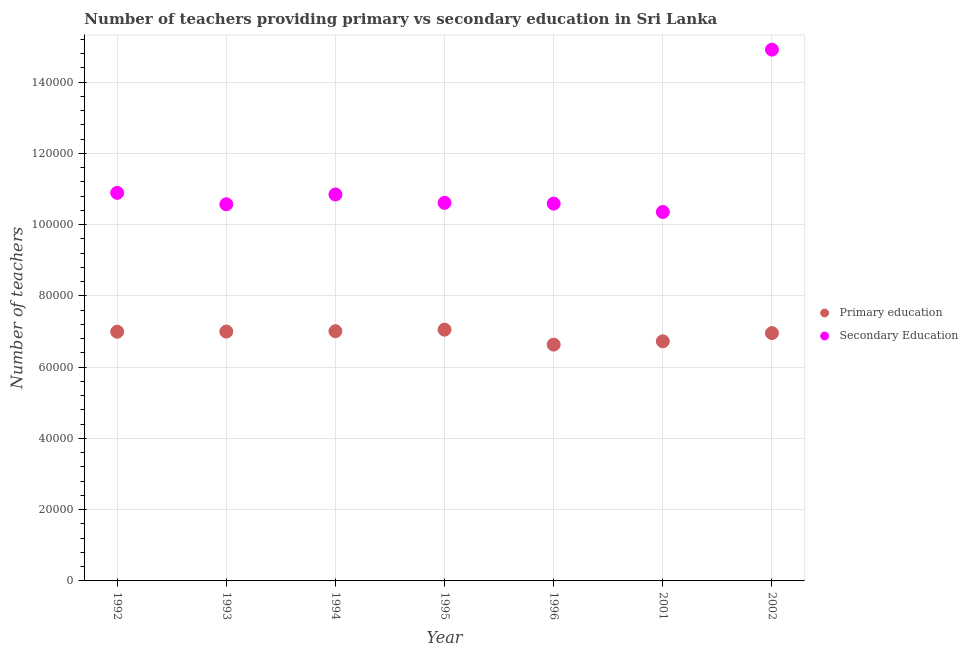How many different coloured dotlines are there?
Make the answer very short. 2. Is the number of dotlines equal to the number of legend labels?
Offer a terse response. Yes. What is the number of primary teachers in 2001?
Provide a short and direct response. 6.73e+04. Across all years, what is the maximum number of primary teachers?
Your answer should be very brief. 7.05e+04. Across all years, what is the minimum number of primary teachers?
Offer a very short reply. 6.63e+04. In which year was the number of secondary teachers minimum?
Offer a terse response. 2001. What is the total number of primary teachers in the graph?
Ensure brevity in your answer.  4.84e+05. What is the difference between the number of primary teachers in 1992 and that in 1993?
Offer a terse response. -43. What is the difference between the number of primary teachers in 1993 and the number of secondary teachers in 1996?
Offer a terse response. -3.59e+04. What is the average number of primary teachers per year?
Offer a very short reply. 6.91e+04. In the year 1993, what is the difference between the number of primary teachers and number of secondary teachers?
Offer a terse response. -3.57e+04. What is the ratio of the number of secondary teachers in 1994 to that in 1995?
Ensure brevity in your answer.  1.02. Is the number of primary teachers in 1996 less than that in 2002?
Keep it short and to the point. Yes. What is the difference between the highest and the second highest number of primary teachers?
Provide a short and direct response. 429. What is the difference between the highest and the lowest number of secondary teachers?
Offer a terse response. 4.56e+04. In how many years, is the number of primary teachers greater than the average number of primary teachers taken over all years?
Your answer should be very brief. 5. Does the number of primary teachers monotonically increase over the years?
Provide a succinct answer. No. Is the number of primary teachers strictly less than the number of secondary teachers over the years?
Keep it short and to the point. Yes. How many dotlines are there?
Keep it short and to the point. 2. How many years are there in the graph?
Offer a terse response. 7. What is the difference between two consecutive major ticks on the Y-axis?
Make the answer very short. 2.00e+04. Does the graph contain any zero values?
Provide a succinct answer. No. Does the graph contain grids?
Your response must be concise. Yes. How many legend labels are there?
Give a very brief answer. 2. How are the legend labels stacked?
Give a very brief answer. Vertical. What is the title of the graph?
Offer a terse response. Number of teachers providing primary vs secondary education in Sri Lanka. What is the label or title of the Y-axis?
Provide a succinct answer. Number of teachers. What is the Number of teachers of Primary education in 1992?
Keep it short and to the point. 7.00e+04. What is the Number of teachers in Secondary Education in 1992?
Give a very brief answer. 1.09e+05. What is the Number of teachers in Primary education in 1993?
Keep it short and to the point. 7.00e+04. What is the Number of teachers in Secondary Education in 1993?
Provide a succinct answer. 1.06e+05. What is the Number of teachers of Primary education in 1994?
Ensure brevity in your answer.  7.01e+04. What is the Number of teachers in Secondary Education in 1994?
Provide a succinct answer. 1.08e+05. What is the Number of teachers in Primary education in 1995?
Your answer should be very brief. 7.05e+04. What is the Number of teachers in Secondary Education in 1995?
Make the answer very short. 1.06e+05. What is the Number of teachers of Primary education in 1996?
Give a very brief answer. 6.63e+04. What is the Number of teachers of Secondary Education in 1996?
Your answer should be very brief. 1.06e+05. What is the Number of teachers in Primary education in 2001?
Your answer should be compact. 6.73e+04. What is the Number of teachers of Secondary Education in 2001?
Provide a short and direct response. 1.04e+05. What is the Number of teachers in Primary education in 2002?
Provide a succinct answer. 6.96e+04. What is the Number of teachers of Secondary Education in 2002?
Offer a very short reply. 1.49e+05. Across all years, what is the maximum Number of teachers in Primary education?
Make the answer very short. 7.05e+04. Across all years, what is the maximum Number of teachers in Secondary Education?
Offer a very short reply. 1.49e+05. Across all years, what is the minimum Number of teachers in Primary education?
Make the answer very short. 6.63e+04. Across all years, what is the minimum Number of teachers in Secondary Education?
Provide a short and direct response. 1.04e+05. What is the total Number of teachers in Primary education in the graph?
Offer a very short reply. 4.84e+05. What is the total Number of teachers of Secondary Education in the graph?
Make the answer very short. 7.88e+05. What is the difference between the Number of teachers in Primary education in 1992 and that in 1993?
Make the answer very short. -43. What is the difference between the Number of teachers of Secondary Education in 1992 and that in 1993?
Make the answer very short. 3202. What is the difference between the Number of teachers in Primary education in 1992 and that in 1994?
Make the answer very short. -143. What is the difference between the Number of teachers of Secondary Education in 1992 and that in 1994?
Your answer should be very brief. 455. What is the difference between the Number of teachers in Primary education in 1992 and that in 1995?
Your answer should be very brief. -572. What is the difference between the Number of teachers of Secondary Education in 1992 and that in 1995?
Make the answer very short. 2803. What is the difference between the Number of teachers of Primary education in 1992 and that in 1996?
Your answer should be very brief. 3626. What is the difference between the Number of teachers of Secondary Education in 1992 and that in 1996?
Make the answer very short. 3028. What is the difference between the Number of teachers of Primary education in 1992 and that in 2001?
Make the answer very short. 2700. What is the difference between the Number of teachers of Secondary Education in 1992 and that in 2001?
Offer a very short reply. 5372. What is the difference between the Number of teachers in Primary education in 1992 and that in 2002?
Provide a short and direct response. 395. What is the difference between the Number of teachers of Secondary Education in 1992 and that in 2002?
Your answer should be very brief. -4.02e+04. What is the difference between the Number of teachers in Primary education in 1993 and that in 1994?
Provide a succinct answer. -100. What is the difference between the Number of teachers of Secondary Education in 1993 and that in 1994?
Provide a short and direct response. -2747. What is the difference between the Number of teachers of Primary education in 1993 and that in 1995?
Your answer should be very brief. -529. What is the difference between the Number of teachers in Secondary Education in 1993 and that in 1995?
Your response must be concise. -399. What is the difference between the Number of teachers of Primary education in 1993 and that in 1996?
Offer a terse response. 3669. What is the difference between the Number of teachers in Secondary Education in 1993 and that in 1996?
Provide a short and direct response. -174. What is the difference between the Number of teachers of Primary education in 1993 and that in 2001?
Make the answer very short. 2743. What is the difference between the Number of teachers in Secondary Education in 1993 and that in 2001?
Your response must be concise. 2170. What is the difference between the Number of teachers of Primary education in 1993 and that in 2002?
Offer a terse response. 438. What is the difference between the Number of teachers of Secondary Education in 1993 and that in 2002?
Your response must be concise. -4.34e+04. What is the difference between the Number of teachers of Primary education in 1994 and that in 1995?
Keep it short and to the point. -429. What is the difference between the Number of teachers in Secondary Education in 1994 and that in 1995?
Keep it short and to the point. 2348. What is the difference between the Number of teachers of Primary education in 1994 and that in 1996?
Keep it short and to the point. 3769. What is the difference between the Number of teachers in Secondary Education in 1994 and that in 1996?
Give a very brief answer. 2573. What is the difference between the Number of teachers in Primary education in 1994 and that in 2001?
Offer a very short reply. 2843. What is the difference between the Number of teachers of Secondary Education in 1994 and that in 2001?
Your response must be concise. 4917. What is the difference between the Number of teachers in Primary education in 1994 and that in 2002?
Offer a terse response. 538. What is the difference between the Number of teachers of Secondary Education in 1994 and that in 2002?
Your answer should be compact. -4.07e+04. What is the difference between the Number of teachers of Primary education in 1995 and that in 1996?
Offer a terse response. 4198. What is the difference between the Number of teachers in Secondary Education in 1995 and that in 1996?
Offer a terse response. 225. What is the difference between the Number of teachers of Primary education in 1995 and that in 2001?
Offer a terse response. 3272. What is the difference between the Number of teachers in Secondary Education in 1995 and that in 2001?
Offer a terse response. 2569. What is the difference between the Number of teachers in Primary education in 1995 and that in 2002?
Your response must be concise. 967. What is the difference between the Number of teachers in Secondary Education in 1995 and that in 2002?
Ensure brevity in your answer.  -4.30e+04. What is the difference between the Number of teachers of Primary education in 1996 and that in 2001?
Provide a succinct answer. -926. What is the difference between the Number of teachers in Secondary Education in 1996 and that in 2001?
Your answer should be compact. 2344. What is the difference between the Number of teachers in Primary education in 1996 and that in 2002?
Give a very brief answer. -3231. What is the difference between the Number of teachers of Secondary Education in 1996 and that in 2002?
Your answer should be very brief. -4.32e+04. What is the difference between the Number of teachers in Primary education in 2001 and that in 2002?
Give a very brief answer. -2305. What is the difference between the Number of teachers of Secondary Education in 2001 and that in 2002?
Ensure brevity in your answer.  -4.56e+04. What is the difference between the Number of teachers in Primary education in 1992 and the Number of teachers in Secondary Education in 1993?
Offer a very short reply. -3.58e+04. What is the difference between the Number of teachers of Primary education in 1992 and the Number of teachers of Secondary Education in 1994?
Give a very brief answer. -3.85e+04. What is the difference between the Number of teachers of Primary education in 1992 and the Number of teachers of Secondary Education in 1995?
Your answer should be compact. -3.62e+04. What is the difference between the Number of teachers in Primary education in 1992 and the Number of teachers in Secondary Education in 1996?
Ensure brevity in your answer.  -3.60e+04. What is the difference between the Number of teachers in Primary education in 1992 and the Number of teachers in Secondary Education in 2001?
Provide a succinct answer. -3.36e+04. What is the difference between the Number of teachers in Primary education in 1992 and the Number of teachers in Secondary Education in 2002?
Keep it short and to the point. -7.92e+04. What is the difference between the Number of teachers in Primary education in 1993 and the Number of teachers in Secondary Education in 1994?
Your response must be concise. -3.85e+04. What is the difference between the Number of teachers in Primary education in 1993 and the Number of teachers in Secondary Education in 1995?
Provide a succinct answer. -3.61e+04. What is the difference between the Number of teachers in Primary education in 1993 and the Number of teachers in Secondary Education in 1996?
Your answer should be compact. -3.59e+04. What is the difference between the Number of teachers of Primary education in 1993 and the Number of teachers of Secondary Education in 2001?
Offer a very short reply. -3.36e+04. What is the difference between the Number of teachers in Primary education in 1993 and the Number of teachers in Secondary Education in 2002?
Keep it short and to the point. -7.91e+04. What is the difference between the Number of teachers in Primary education in 1994 and the Number of teachers in Secondary Education in 1995?
Provide a succinct answer. -3.60e+04. What is the difference between the Number of teachers in Primary education in 1994 and the Number of teachers in Secondary Education in 1996?
Give a very brief answer. -3.58e+04. What is the difference between the Number of teachers in Primary education in 1994 and the Number of teachers in Secondary Education in 2001?
Provide a succinct answer. -3.35e+04. What is the difference between the Number of teachers in Primary education in 1994 and the Number of teachers in Secondary Education in 2002?
Your response must be concise. -7.90e+04. What is the difference between the Number of teachers of Primary education in 1995 and the Number of teachers of Secondary Education in 1996?
Keep it short and to the point. -3.54e+04. What is the difference between the Number of teachers in Primary education in 1995 and the Number of teachers in Secondary Education in 2001?
Provide a short and direct response. -3.30e+04. What is the difference between the Number of teachers of Primary education in 1995 and the Number of teachers of Secondary Education in 2002?
Offer a terse response. -7.86e+04. What is the difference between the Number of teachers in Primary education in 1996 and the Number of teachers in Secondary Education in 2001?
Provide a short and direct response. -3.72e+04. What is the difference between the Number of teachers of Primary education in 1996 and the Number of teachers of Secondary Education in 2002?
Ensure brevity in your answer.  -8.28e+04. What is the difference between the Number of teachers in Primary education in 2001 and the Number of teachers in Secondary Education in 2002?
Ensure brevity in your answer.  -8.19e+04. What is the average Number of teachers of Primary education per year?
Give a very brief answer. 6.91e+04. What is the average Number of teachers of Secondary Education per year?
Provide a short and direct response. 1.13e+05. In the year 1992, what is the difference between the Number of teachers in Primary education and Number of teachers in Secondary Education?
Give a very brief answer. -3.90e+04. In the year 1993, what is the difference between the Number of teachers of Primary education and Number of teachers of Secondary Education?
Your answer should be compact. -3.57e+04. In the year 1994, what is the difference between the Number of teachers of Primary education and Number of teachers of Secondary Education?
Your response must be concise. -3.84e+04. In the year 1995, what is the difference between the Number of teachers of Primary education and Number of teachers of Secondary Education?
Your response must be concise. -3.56e+04. In the year 1996, what is the difference between the Number of teachers of Primary education and Number of teachers of Secondary Education?
Your response must be concise. -3.96e+04. In the year 2001, what is the difference between the Number of teachers in Primary education and Number of teachers in Secondary Education?
Make the answer very short. -3.63e+04. In the year 2002, what is the difference between the Number of teachers of Primary education and Number of teachers of Secondary Education?
Give a very brief answer. -7.96e+04. What is the ratio of the Number of teachers of Secondary Education in 1992 to that in 1993?
Ensure brevity in your answer.  1.03. What is the ratio of the Number of teachers in Primary education in 1992 to that in 1994?
Make the answer very short. 1. What is the ratio of the Number of teachers of Secondary Education in 1992 to that in 1994?
Offer a very short reply. 1. What is the ratio of the Number of teachers in Secondary Education in 1992 to that in 1995?
Ensure brevity in your answer.  1.03. What is the ratio of the Number of teachers of Primary education in 1992 to that in 1996?
Provide a short and direct response. 1.05. What is the ratio of the Number of teachers of Secondary Education in 1992 to that in 1996?
Offer a very short reply. 1.03. What is the ratio of the Number of teachers in Primary education in 1992 to that in 2001?
Keep it short and to the point. 1.04. What is the ratio of the Number of teachers of Secondary Education in 1992 to that in 2001?
Offer a very short reply. 1.05. What is the ratio of the Number of teachers of Secondary Education in 1992 to that in 2002?
Provide a succinct answer. 0.73. What is the ratio of the Number of teachers of Primary education in 1993 to that in 1994?
Your answer should be very brief. 1. What is the ratio of the Number of teachers of Secondary Education in 1993 to that in 1994?
Provide a short and direct response. 0.97. What is the ratio of the Number of teachers in Primary education in 1993 to that in 1995?
Provide a succinct answer. 0.99. What is the ratio of the Number of teachers of Secondary Education in 1993 to that in 1995?
Keep it short and to the point. 1. What is the ratio of the Number of teachers in Primary education in 1993 to that in 1996?
Offer a very short reply. 1.06. What is the ratio of the Number of teachers of Secondary Education in 1993 to that in 1996?
Ensure brevity in your answer.  1. What is the ratio of the Number of teachers in Primary education in 1993 to that in 2001?
Make the answer very short. 1.04. What is the ratio of the Number of teachers in Primary education in 1993 to that in 2002?
Your answer should be very brief. 1.01. What is the ratio of the Number of teachers of Secondary Education in 1993 to that in 2002?
Keep it short and to the point. 0.71. What is the ratio of the Number of teachers of Secondary Education in 1994 to that in 1995?
Your answer should be very brief. 1.02. What is the ratio of the Number of teachers of Primary education in 1994 to that in 1996?
Offer a very short reply. 1.06. What is the ratio of the Number of teachers of Secondary Education in 1994 to that in 1996?
Keep it short and to the point. 1.02. What is the ratio of the Number of teachers of Primary education in 1994 to that in 2001?
Provide a short and direct response. 1.04. What is the ratio of the Number of teachers of Secondary Education in 1994 to that in 2001?
Provide a succinct answer. 1.05. What is the ratio of the Number of teachers of Primary education in 1994 to that in 2002?
Keep it short and to the point. 1.01. What is the ratio of the Number of teachers of Secondary Education in 1994 to that in 2002?
Provide a succinct answer. 0.73. What is the ratio of the Number of teachers of Primary education in 1995 to that in 1996?
Provide a short and direct response. 1.06. What is the ratio of the Number of teachers in Secondary Education in 1995 to that in 1996?
Keep it short and to the point. 1. What is the ratio of the Number of teachers of Primary education in 1995 to that in 2001?
Your response must be concise. 1.05. What is the ratio of the Number of teachers of Secondary Education in 1995 to that in 2001?
Your answer should be very brief. 1.02. What is the ratio of the Number of teachers of Primary education in 1995 to that in 2002?
Provide a succinct answer. 1.01. What is the ratio of the Number of teachers in Secondary Education in 1995 to that in 2002?
Offer a terse response. 0.71. What is the ratio of the Number of teachers of Primary education in 1996 to that in 2001?
Make the answer very short. 0.99. What is the ratio of the Number of teachers of Secondary Education in 1996 to that in 2001?
Give a very brief answer. 1.02. What is the ratio of the Number of teachers of Primary education in 1996 to that in 2002?
Provide a succinct answer. 0.95. What is the ratio of the Number of teachers of Secondary Education in 1996 to that in 2002?
Your answer should be compact. 0.71. What is the ratio of the Number of teachers in Primary education in 2001 to that in 2002?
Make the answer very short. 0.97. What is the ratio of the Number of teachers in Secondary Education in 2001 to that in 2002?
Provide a short and direct response. 0.69. What is the difference between the highest and the second highest Number of teachers in Primary education?
Your answer should be compact. 429. What is the difference between the highest and the second highest Number of teachers in Secondary Education?
Give a very brief answer. 4.02e+04. What is the difference between the highest and the lowest Number of teachers of Primary education?
Your answer should be compact. 4198. What is the difference between the highest and the lowest Number of teachers in Secondary Education?
Give a very brief answer. 4.56e+04. 